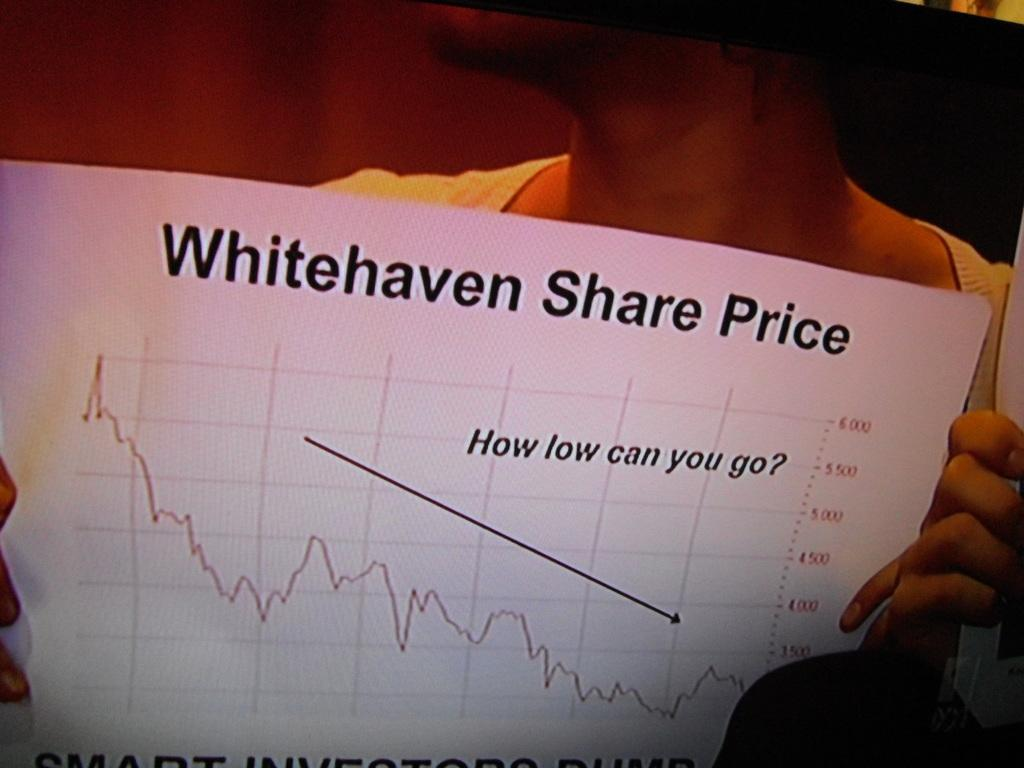Who or what is present in the image? There is a person in the image. What is the person holding in the image? The person is holding a white paper. What can be seen on the paper? There is text and a graph on the paper. What type of chair is the person sitting on in the image? There is no chair present in the image; the person is holding a white paper. What color is the yarn used to create the graph on the paper? There is no yarn present in the image; the graph is likely created using ink or another printing method. 